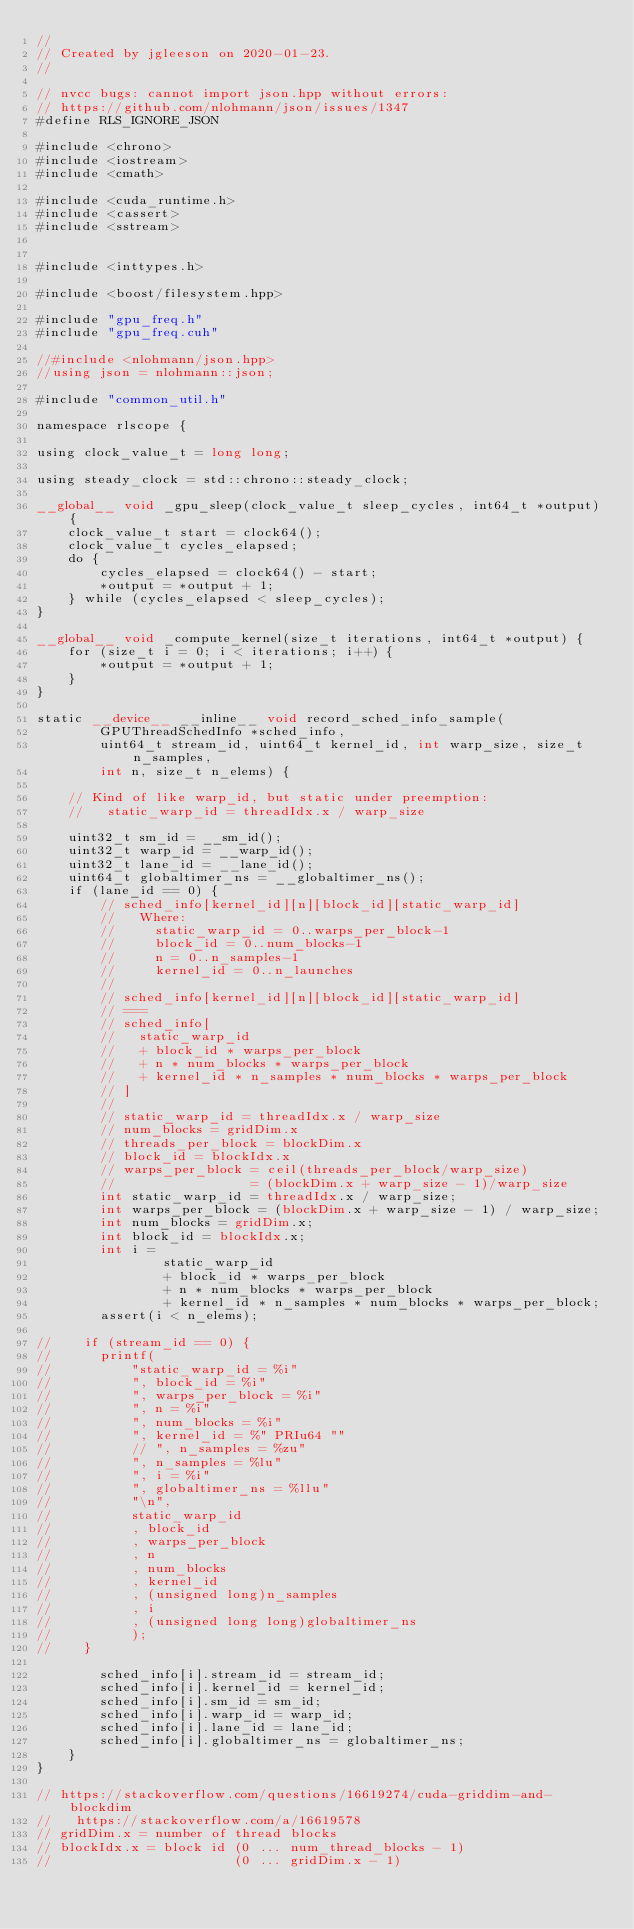<code> <loc_0><loc_0><loc_500><loc_500><_Cuda_>//
// Created by jgleeson on 2020-01-23.
//

// nvcc bugs: cannot import json.hpp without errors:
// https://github.com/nlohmann/json/issues/1347
#define RLS_IGNORE_JSON

#include <chrono>
#include <iostream>
#include <cmath>

#include <cuda_runtime.h>
#include <cassert>
#include <sstream>


#include <inttypes.h>

#include <boost/filesystem.hpp>

#include "gpu_freq.h"
#include "gpu_freq.cuh"

//#include <nlohmann/json.hpp>
//using json = nlohmann::json;

#include "common_util.h"

namespace rlscope {

using clock_value_t = long long;

using steady_clock = std::chrono::steady_clock;

__global__ void _gpu_sleep(clock_value_t sleep_cycles, int64_t *output) {
    clock_value_t start = clock64();
    clock_value_t cycles_elapsed;
    do {
        cycles_elapsed = clock64() - start;
        *output = *output + 1;
    } while (cycles_elapsed < sleep_cycles);
}

__global__ void _compute_kernel(size_t iterations, int64_t *output) {
    for (size_t i = 0; i < iterations; i++) {
        *output = *output + 1;
    }
}

static __device__ __inline__ void record_sched_info_sample(
        GPUThreadSchedInfo *sched_info,
        uint64_t stream_id, uint64_t kernel_id, int warp_size, size_t n_samples,
        int n, size_t n_elems) {

    // Kind of like warp_id, but static under preemption:
    //   static_warp_id = threadIdx.x / warp_size

    uint32_t sm_id = __sm_id();
    uint32_t warp_id = __warp_id();
    uint32_t lane_id = __lane_id();
    uint64_t globaltimer_ns = __globaltimer_ns();
    if (lane_id == 0) {
        // sched_info[kernel_id][n][block_id][static_warp_id]
        //   Where:
        //     static_warp_id = 0..warps_per_block-1
        //     block_id = 0..num_blocks-1
        //     n = 0..n_samples-1
        //     kernel_id = 0..n_launches
        //
        // sched_info[kernel_id][n][block_id][static_warp_id]
        // ===
        // sched_info[
        //   static_warp_id
        //   + block_id * warps_per_block
        //   + n * num_blocks * warps_per_block
        //   + kernel_id * n_samples * num_blocks * warps_per_block
        // ]
        //
        // static_warp_id = threadIdx.x / warp_size
        // num_blocks = gridDim.x
        // threads_per_block = blockDim.x
        // block_id = blockIdx.x
        // warps_per_block = ceil(threads_per_block/warp_size)
        //                 = (blockDim.x + warp_size - 1)/warp_size
        int static_warp_id = threadIdx.x / warp_size;
        int warps_per_block = (blockDim.x + warp_size - 1) / warp_size;
        int num_blocks = gridDim.x;
        int block_id = blockIdx.x;
        int i =
                static_warp_id
                + block_id * warps_per_block
                + n * num_blocks * warps_per_block
                + kernel_id * n_samples * num_blocks * warps_per_block;
        assert(i < n_elems);

//    if (stream_id == 0) {
//      printf(
//          "static_warp_id = %i"
//          ", block_id = %i"
//          ", warps_per_block = %i"
//          ", n = %i"
//          ", num_blocks = %i"
//          ", kernel_id = %" PRIu64 ""
//          // ", n_samples = %zu"
//          ", n_samples = %lu"
//          ", i = %i"
//          ", globaltimer_ns = %llu"
//          "\n",
//          static_warp_id
//          , block_id
//          , warps_per_block
//          , n
//          , num_blocks
//          , kernel_id
//          , (unsigned long)n_samples
//          , i
//          , (unsigned long long)globaltimer_ns
//          );
//    }

        sched_info[i].stream_id = stream_id;
        sched_info[i].kernel_id = kernel_id;
        sched_info[i].sm_id = sm_id;
        sched_info[i].warp_id = warp_id;
        sched_info[i].lane_id = lane_id;
        sched_info[i].globaltimer_ns = globaltimer_ns;
    }
}

// https://stackoverflow.com/questions/16619274/cuda-griddim-and-blockdim
//   https://stackoverflow.com/a/16619578
// gridDim.x = number of thread blocks
// blockIdx.x = block id (0 ... num_thread_blocks - 1)
//                       (0 ... gridDim.x - 1)</code> 